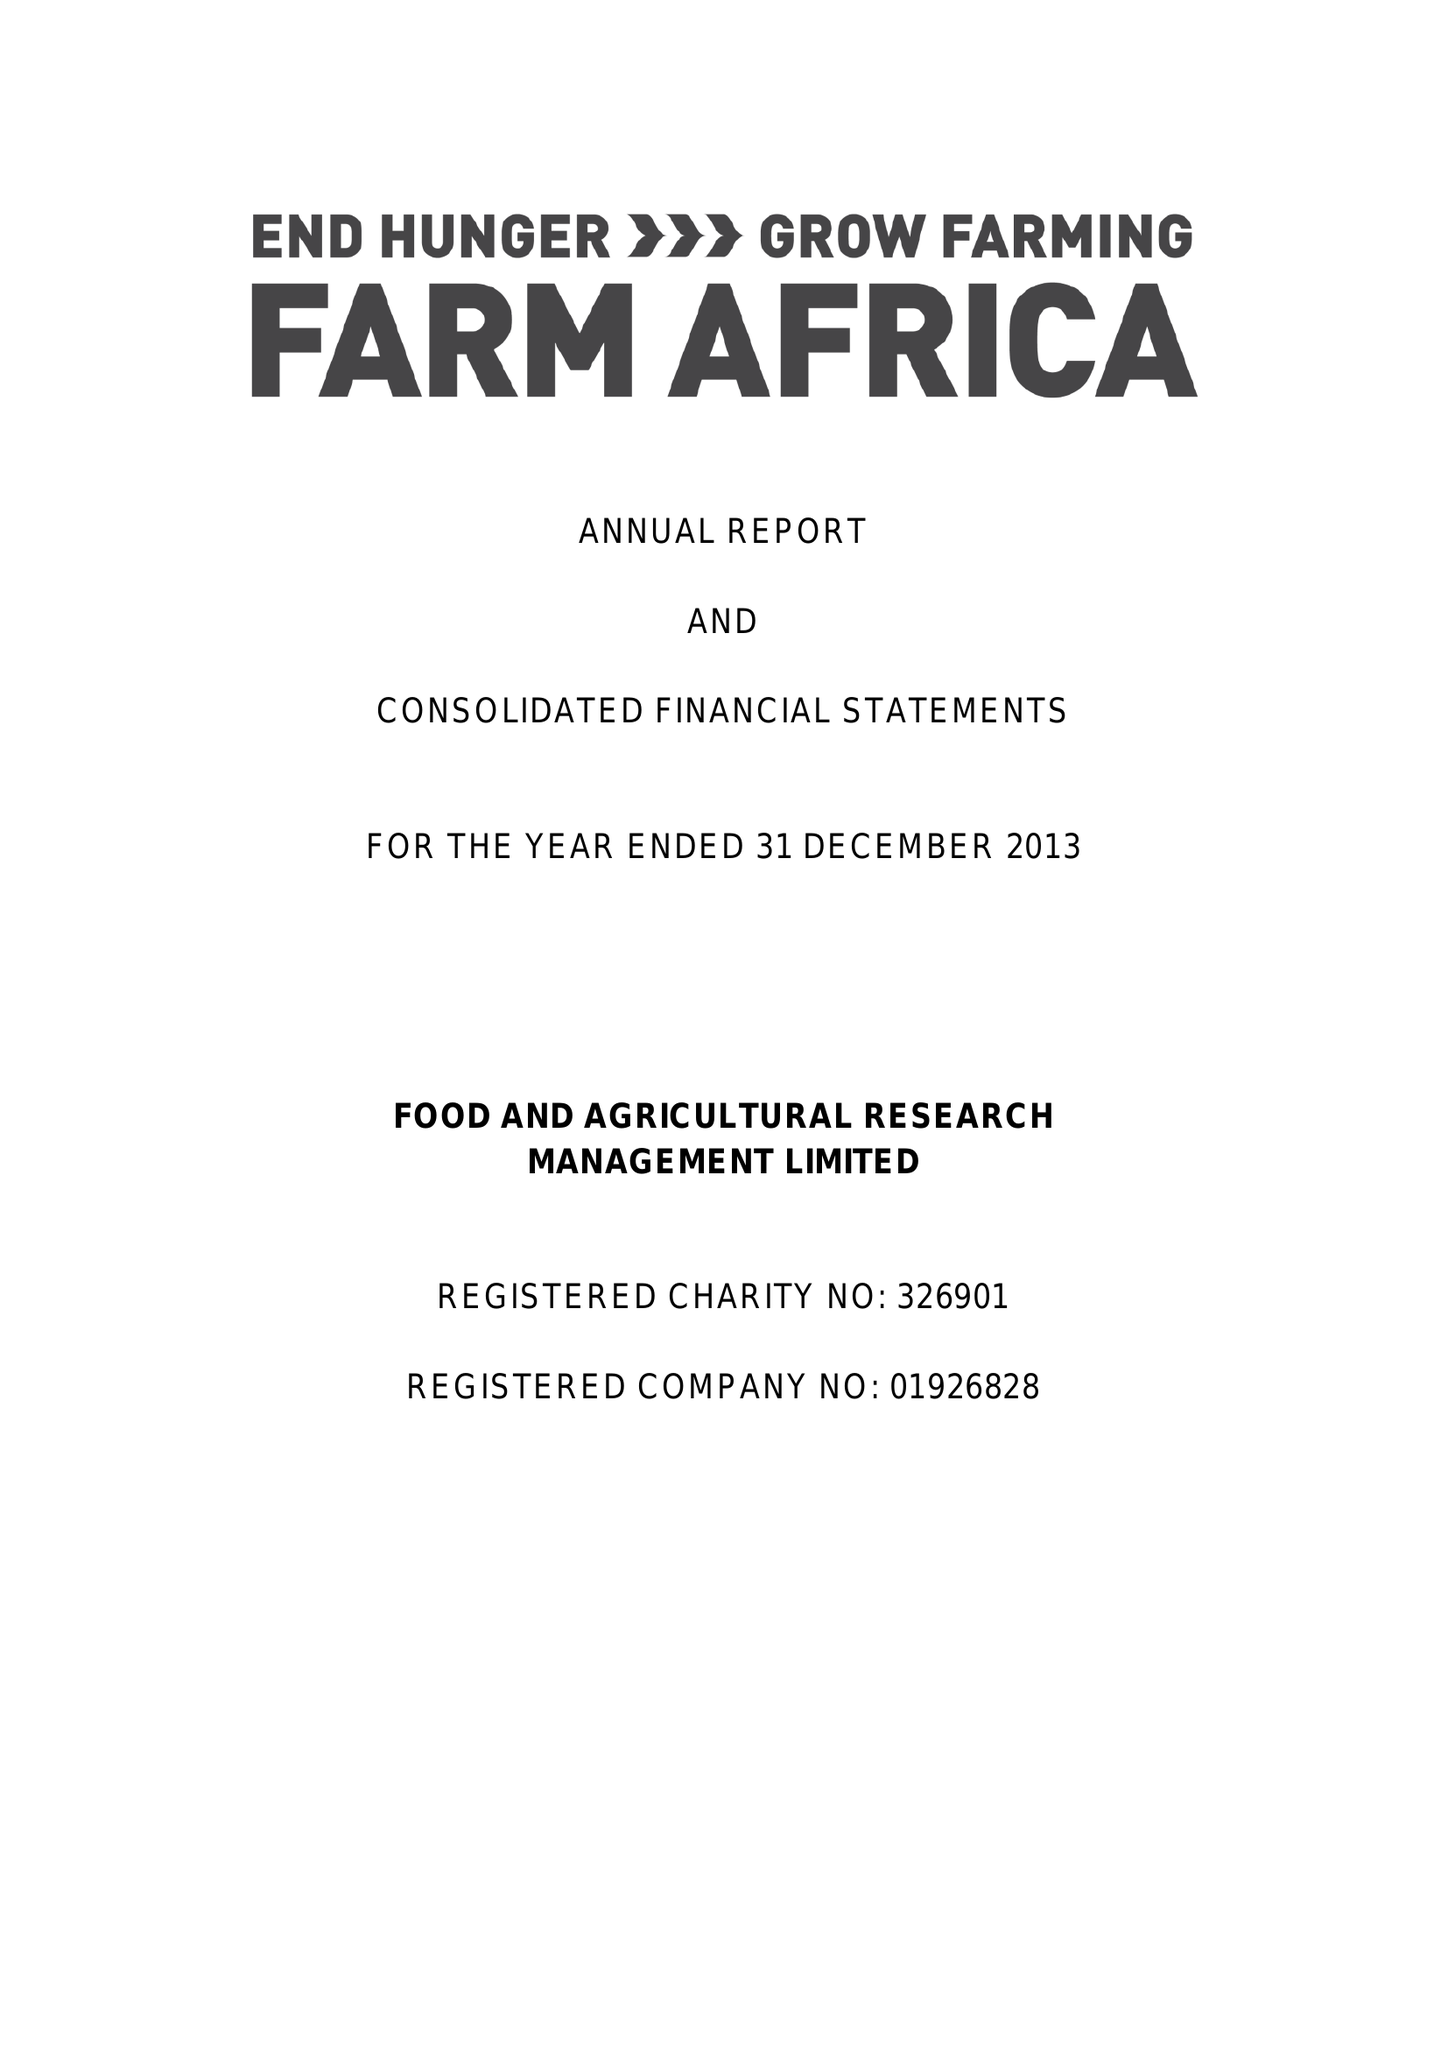What is the value for the income_annually_in_british_pounds?
Answer the question using a single word or phrase. 12822000.00 